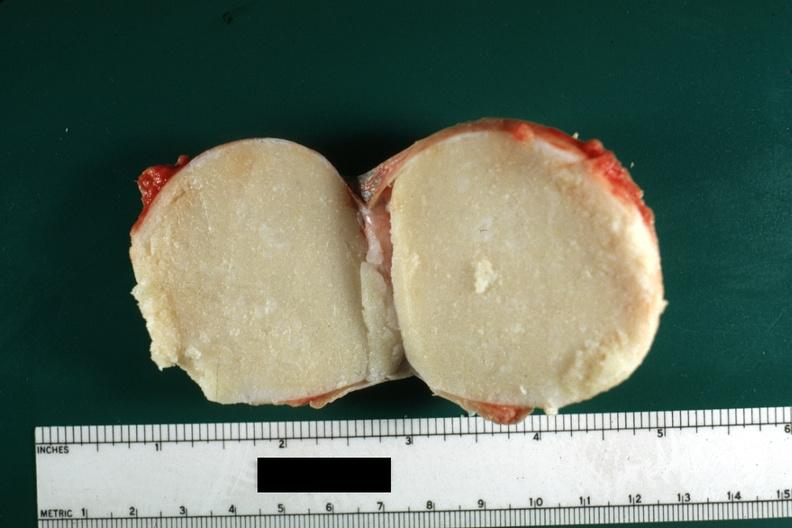how was cut surface typical cheese like yellow content and thin fibrous capsule this lesion from the skin?
Answer the question using a single word or phrase. Scrotal 